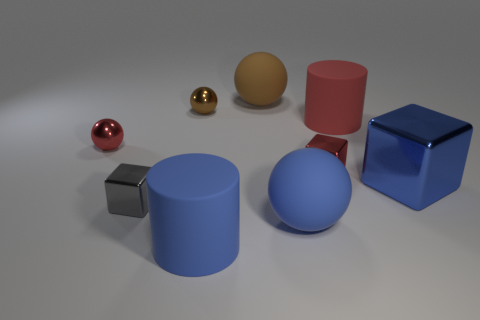Subtract all brown metal spheres. How many spheres are left? 3 Add 1 matte balls. How many objects exist? 10 Subtract all red balls. How many balls are left? 3 Subtract all blocks. How many objects are left? 6 Add 2 matte things. How many matte things are left? 6 Add 7 green rubber cylinders. How many green rubber cylinders exist? 7 Subtract 0 green balls. How many objects are left? 9 Subtract 2 spheres. How many spheres are left? 2 Subtract all cyan cylinders. Subtract all brown blocks. How many cylinders are left? 2 Subtract all gray cylinders. How many brown balls are left? 2 